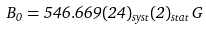Convert formula to latex. <formula><loc_0><loc_0><loc_500><loc_500>B _ { 0 } = 5 4 6 . 6 6 9 ( 2 4 ) _ { s y s t } ( 2 ) _ { s t a t } \, G</formula> 